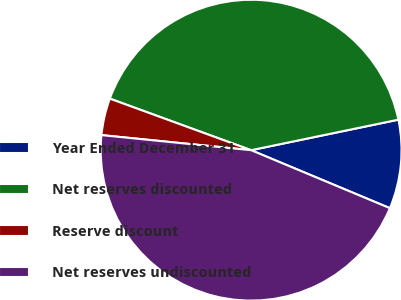Convert chart. <chart><loc_0><loc_0><loc_500><loc_500><pie_chart><fcel>Year Ended December 31<fcel>Net reserves discounted<fcel>Reserve discount<fcel>Net reserves undiscounted<nl><fcel>9.55%<fcel>41.18%<fcel>3.97%<fcel>45.3%<nl></chart> 